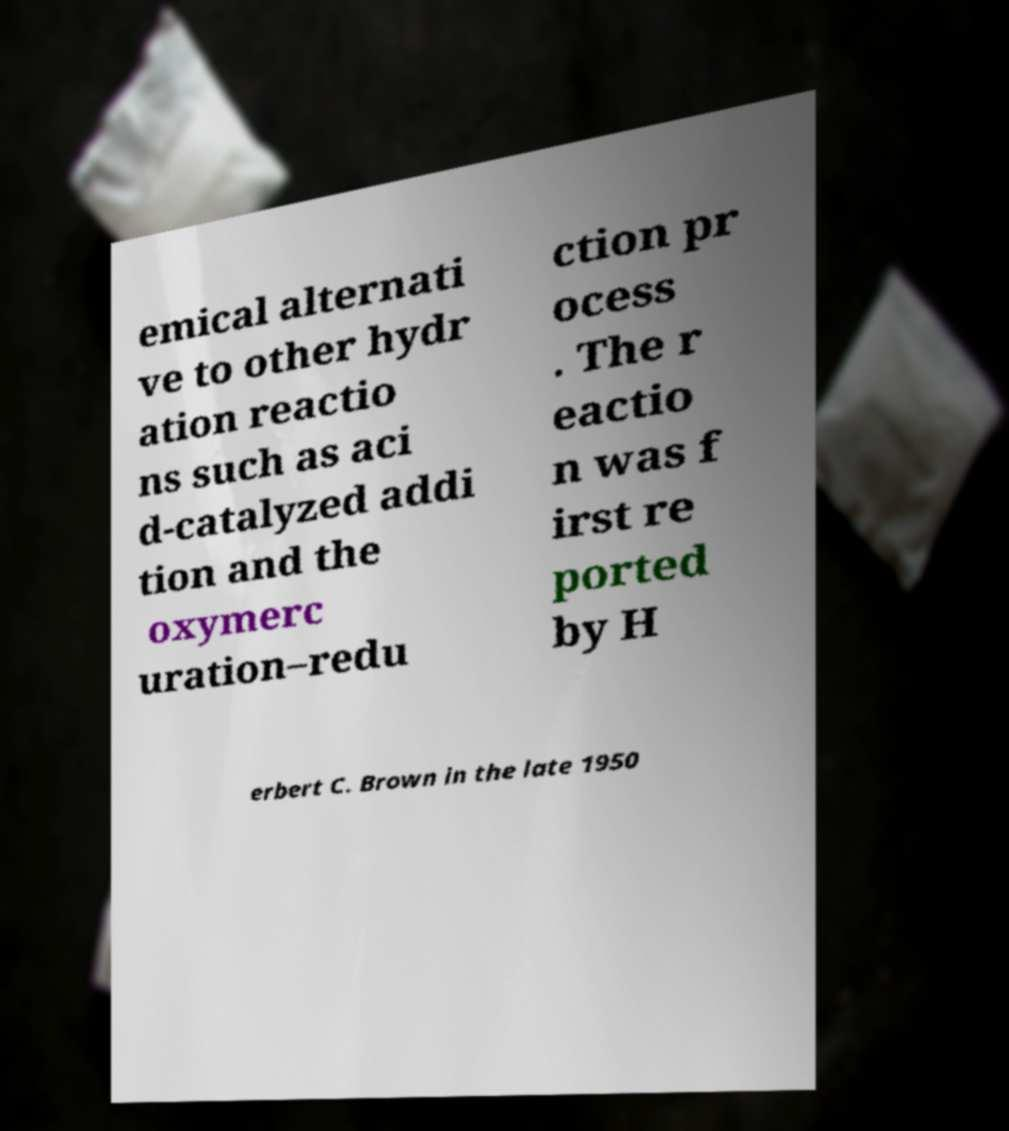Can you read and provide the text displayed in the image?This photo seems to have some interesting text. Can you extract and type it out for me? emical alternati ve to other hydr ation reactio ns such as aci d-catalyzed addi tion and the oxymerc uration–redu ction pr ocess . The r eactio n was f irst re ported by H erbert C. Brown in the late 1950 